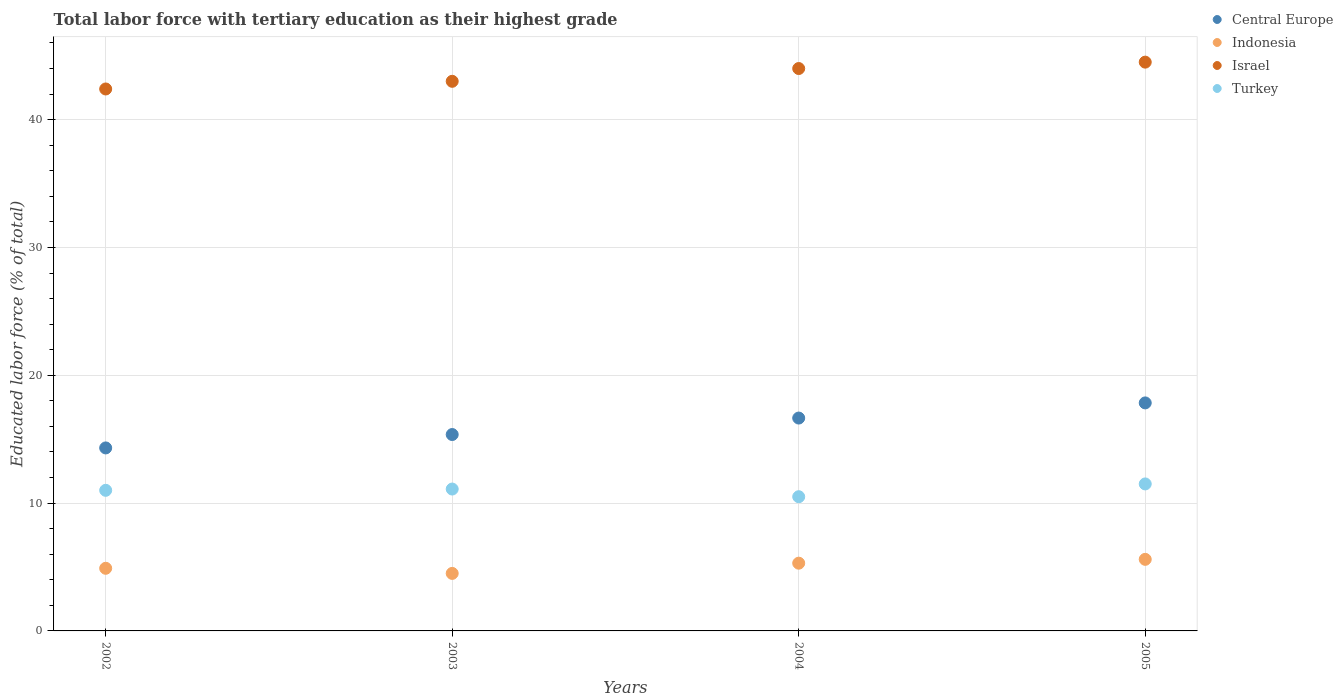How many different coloured dotlines are there?
Keep it short and to the point. 4. Is the number of dotlines equal to the number of legend labels?
Your answer should be very brief. Yes. What is the percentage of male labor force with tertiary education in Indonesia in 2005?
Give a very brief answer. 5.6. Across all years, what is the maximum percentage of male labor force with tertiary education in Turkey?
Offer a very short reply. 11.5. Across all years, what is the minimum percentage of male labor force with tertiary education in Israel?
Keep it short and to the point. 42.4. What is the total percentage of male labor force with tertiary education in Turkey in the graph?
Your answer should be compact. 44.1. What is the difference between the percentage of male labor force with tertiary education in Central Europe in 2002 and that in 2004?
Your response must be concise. -2.34. What is the difference between the percentage of male labor force with tertiary education in Turkey in 2004 and the percentage of male labor force with tertiary education in Indonesia in 2002?
Offer a very short reply. 5.6. What is the average percentage of male labor force with tertiary education in Central Europe per year?
Your answer should be very brief. 16.04. In the year 2004, what is the difference between the percentage of male labor force with tertiary education in Central Europe and percentage of male labor force with tertiary education in Indonesia?
Provide a succinct answer. 11.35. What is the ratio of the percentage of male labor force with tertiary education in Israel in 2003 to that in 2005?
Your answer should be compact. 0.97. Is the percentage of male labor force with tertiary education in Turkey in 2003 less than that in 2005?
Keep it short and to the point. Yes. Is the difference between the percentage of male labor force with tertiary education in Central Europe in 2003 and 2005 greater than the difference between the percentage of male labor force with tertiary education in Indonesia in 2003 and 2005?
Offer a very short reply. No. What is the difference between the highest and the second highest percentage of male labor force with tertiary education in Turkey?
Offer a very short reply. 0.4. What is the difference between the highest and the lowest percentage of male labor force with tertiary education in Central Europe?
Provide a succinct answer. 3.52. Is it the case that in every year, the sum of the percentage of male labor force with tertiary education in Indonesia and percentage of male labor force with tertiary education in Turkey  is greater than the percentage of male labor force with tertiary education in Israel?
Provide a short and direct response. No. How many years are there in the graph?
Keep it short and to the point. 4. What is the difference between two consecutive major ticks on the Y-axis?
Offer a terse response. 10. Are the values on the major ticks of Y-axis written in scientific E-notation?
Offer a very short reply. No. Does the graph contain any zero values?
Your answer should be compact. No. Does the graph contain grids?
Offer a terse response. Yes. Where does the legend appear in the graph?
Make the answer very short. Top right. How many legend labels are there?
Offer a terse response. 4. How are the legend labels stacked?
Provide a short and direct response. Vertical. What is the title of the graph?
Provide a succinct answer. Total labor force with tertiary education as their highest grade. Does "Swaziland" appear as one of the legend labels in the graph?
Provide a succinct answer. No. What is the label or title of the X-axis?
Keep it short and to the point. Years. What is the label or title of the Y-axis?
Offer a terse response. Educated labor force (% of total). What is the Educated labor force (% of total) in Central Europe in 2002?
Provide a succinct answer. 14.32. What is the Educated labor force (% of total) of Indonesia in 2002?
Offer a terse response. 4.9. What is the Educated labor force (% of total) of Israel in 2002?
Provide a succinct answer. 42.4. What is the Educated labor force (% of total) in Central Europe in 2003?
Your response must be concise. 15.37. What is the Educated labor force (% of total) in Indonesia in 2003?
Make the answer very short. 4.5. What is the Educated labor force (% of total) in Israel in 2003?
Your answer should be very brief. 43. What is the Educated labor force (% of total) in Turkey in 2003?
Your response must be concise. 11.1. What is the Educated labor force (% of total) in Central Europe in 2004?
Your answer should be very brief. 16.65. What is the Educated labor force (% of total) of Indonesia in 2004?
Offer a terse response. 5.3. What is the Educated labor force (% of total) of Israel in 2004?
Make the answer very short. 44. What is the Educated labor force (% of total) in Central Europe in 2005?
Offer a very short reply. 17.84. What is the Educated labor force (% of total) of Indonesia in 2005?
Keep it short and to the point. 5.6. What is the Educated labor force (% of total) of Israel in 2005?
Provide a succinct answer. 44.5. What is the Educated labor force (% of total) of Turkey in 2005?
Offer a terse response. 11.5. Across all years, what is the maximum Educated labor force (% of total) in Central Europe?
Ensure brevity in your answer.  17.84. Across all years, what is the maximum Educated labor force (% of total) in Indonesia?
Offer a very short reply. 5.6. Across all years, what is the maximum Educated labor force (% of total) in Israel?
Your answer should be compact. 44.5. Across all years, what is the minimum Educated labor force (% of total) of Central Europe?
Your answer should be very brief. 14.32. Across all years, what is the minimum Educated labor force (% of total) in Israel?
Your response must be concise. 42.4. What is the total Educated labor force (% of total) of Central Europe in the graph?
Your answer should be compact. 64.18. What is the total Educated labor force (% of total) in Indonesia in the graph?
Offer a very short reply. 20.3. What is the total Educated labor force (% of total) of Israel in the graph?
Offer a terse response. 173.9. What is the total Educated labor force (% of total) in Turkey in the graph?
Keep it short and to the point. 44.1. What is the difference between the Educated labor force (% of total) in Central Europe in 2002 and that in 2003?
Your answer should be compact. -1.05. What is the difference between the Educated labor force (% of total) in Indonesia in 2002 and that in 2003?
Offer a terse response. 0.4. What is the difference between the Educated labor force (% of total) of Central Europe in 2002 and that in 2004?
Provide a succinct answer. -2.34. What is the difference between the Educated labor force (% of total) of Indonesia in 2002 and that in 2004?
Keep it short and to the point. -0.4. What is the difference between the Educated labor force (% of total) in Turkey in 2002 and that in 2004?
Ensure brevity in your answer.  0.5. What is the difference between the Educated labor force (% of total) in Central Europe in 2002 and that in 2005?
Make the answer very short. -3.52. What is the difference between the Educated labor force (% of total) of Central Europe in 2003 and that in 2004?
Offer a very short reply. -1.29. What is the difference between the Educated labor force (% of total) of Israel in 2003 and that in 2004?
Provide a short and direct response. -1. What is the difference between the Educated labor force (% of total) in Turkey in 2003 and that in 2004?
Offer a terse response. 0.6. What is the difference between the Educated labor force (% of total) in Central Europe in 2003 and that in 2005?
Your answer should be very brief. -2.47. What is the difference between the Educated labor force (% of total) of Central Europe in 2004 and that in 2005?
Ensure brevity in your answer.  -1.19. What is the difference between the Educated labor force (% of total) in Indonesia in 2004 and that in 2005?
Your answer should be compact. -0.3. What is the difference between the Educated labor force (% of total) of Israel in 2004 and that in 2005?
Your answer should be very brief. -0.5. What is the difference between the Educated labor force (% of total) of Central Europe in 2002 and the Educated labor force (% of total) of Indonesia in 2003?
Your answer should be very brief. 9.82. What is the difference between the Educated labor force (% of total) in Central Europe in 2002 and the Educated labor force (% of total) in Israel in 2003?
Provide a succinct answer. -28.68. What is the difference between the Educated labor force (% of total) of Central Europe in 2002 and the Educated labor force (% of total) of Turkey in 2003?
Your answer should be very brief. 3.22. What is the difference between the Educated labor force (% of total) of Indonesia in 2002 and the Educated labor force (% of total) of Israel in 2003?
Provide a short and direct response. -38.1. What is the difference between the Educated labor force (% of total) in Indonesia in 2002 and the Educated labor force (% of total) in Turkey in 2003?
Make the answer very short. -6.2. What is the difference between the Educated labor force (% of total) of Israel in 2002 and the Educated labor force (% of total) of Turkey in 2003?
Make the answer very short. 31.3. What is the difference between the Educated labor force (% of total) of Central Europe in 2002 and the Educated labor force (% of total) of Indonesia in 2004?
Your response must be concise. 9.02. What is the difference between the Educated labor force (% of total) in Central Europe in 2002 and the Educated labor force (% of total) in Israel in 2004?
Keep it short and to the point. -29.68. What is the difference between the Educated labor force (% of total) of Central Europe in 2002 and the Educated labor force (% of total) of Turkey in 2004?
Keep it short and to the point. 3.82. What is the difference between the Educated labor force (% of total) of Indonesia in 2002 and the Educated labor force (% of total) of Israel in 2004?
Your answer should be very brief. -39.1. What is the difference between the Educated labor force (% of total) of Indonesia in 2002 and the Educated labor force (% of total) of Turkey in 2004?
Provide a succinct answer. -5.6. What is the difference between the Educated labor force (% of total) of Israel in 2002 and the Educated labor force (% of total) of Turkey in 2004?
Your response must be concise. 31.9. What is the difference between the Educated labor force (% of total) of Central Europe in 2002 and the Educated labor force (% of total) of Indonesia in 2005?
Ensure brevity in your answer.  8.72. What is the difference between the Educated labor force (% of total) of Central Europe in 2002 and the Educated labor force (% of total) of Israel in 2005?
Provide a succinct answer. -30.18. What is the difference between the Educated labor force (% of total) in Central Europe in 2002 and the Educated labor force (% of total) in Turkey in 2005?
Offer a very short reply. 2.82. What is the difference between the Educated labor force (% of total) of Indonesia in 2002 and the Educated labor force (% of total) of Israel in 2005?
Provide a succinct answer. -39.6. What is the difference between the Educated labor force (% of total) of Indonesia in 2002 and the Educated labor force (% of total) of Turkey in 2005?
Offer a very short reply. -6.6. What is the difference between the Educated labor force (% of total) of Israel in 2002 and the Educated labor force (% of total) of Turkey in 2005?
Offer a terse response. 30.9. What is the difference between the Educated labor force (% of total) of Central Europe in 2003 and the Educated labor force (% of total) of Indonesia in 2004?
Offer a very short reply. 10.06. What is the difference between the Educated labor force (% of total) in Central Europe in 2003 and the Educated labor force (% of total) in Israel in 2004?
Your response must be concise. -28.64. What is the difference between the Educated labor force (% of total) in Central Europe in 2003 and the Educated labor force (% of total) in Turkey in 2004?
Ensure brevity in your answer.  4.87. What is the difference between the Educated labor force (% of total) of Indonesia in 2003 and the Educated labor force (% of total) of Israel in 2004?
Your response must be concise. -39.5. What is the difference between the Educated labor force (% of total) of Israel in 2003 and the Educated labor force (% of total) of Turkey in 2004?
Offer a very short reply. 32.5. What is the difference between the Educated labor force (% of total) of Central Europe in 2003 and the Educated labor force (% of total) of Indonesia in 2005?
Provide a short and direct response. 9.77. What is the difference between the Educated labor force (% of total) of Central Europe in 2003 and the Educated labor force (% of total) of Israel in 2005?
Your answer should be very brief. -29.14. What is the difference between the Educated labor force (% of total) of Central Europe in 2003 and the Educated labor force (% of total) of Turkey in 2005?
Give a very brief answer. 3.87. What is the difference between the Educated labor force (% of total) in Israel in 2003 and the Educated labor force (% of total) in Turkey in 2005?
Your response must be concise. 31.5. What is the difference between the Educated labor force (% of total) of Central Europe in 2004 and the Educated labor force (% of total) of Indonesia in 2005?
Keep it short and to the point. 11.05. What is the difference between the Educated labor force (% of total) of Central Europe in 2004 and the Educated labor force (% of total) of Israel in 2005?
Your answer should be compact. -27.85. What is the difference between the Educated labor force (% of total) of Central Europe in 2004 and the Educated labor force (% of total) of Turkey in 2005?
Provide a succinct answer. 5.15. What is the difference between the Educated labor force (% of total) of Indonesia in 2004 and the Educated labor force (% of total) of Israel in 2005?
Your response must be concise. -39.2. What is the difference between the Educated labor force (% of total) in Indonesia in 2004 and the Educated labor force (% of total) in Turkey in 2005?
Provide a short and direct response. -6.2. What is the difference between the Educated labor force (% of total) of Israel in 2004 and the Educated labor force (% of total) of Turkey in 2005?
Offer a terse response. 32.5. What is the average Educated labor force (% of total) in Central Europe per year?
Your answer should be compact. 16.04. What is the average Educated labor force (% of total) in Indonesia per year?
Your answer should be very brief. 5.08. What is the average Educated labor force (% of total) of Israel per year?
Make the answer very short. 43.48. What is the average Educated labor force (% of total) of Turkey per year?
Keep it short and to the point. 11.03. In the year 2002, what is the difference between the Educated labor force (% of total) of Central Europe and Educated labor force (% of total) of Indonesia?
Make the answer very short. 9.42. In the year 2002, what is the difference between the Educated labor force (% of total) of Central Europe and Educated labor force (% of total) of Israel?
Ensure brevity in your answer.  -28.08. In the year 2002, what is the difference between the Educated labor force (% of total) of Central Europe and Educated labor force (% of total) of Turkey?
Your answer should be very brief. 3.32. In the year 2002, what is the difference between the Educated labor force (% of total) in Indonesia and Educated labor force (% of total) in Israel?
Offer a terse response. -37.5. In the year 2002, what is the difference between the Educated labor force (% of total) of Israel and Educated labor force (% of total) of Turkey?
Give a very brief answer. 31.4. In the year 2003, what is the difference between the Educated labor force (% of total) in Central Europe and Educated labor force (% of total) in Indonesia?
Keep it short and to the point. 10.87. In the year 2003, what is the difference between the Educated labor force (% of total) in Central Europe and Educated labor force (% of total) in Israel?
Ensure brevity in your answer.  -27.64. In the year 2003, what is the difference between the Educated labor force (% of total) in Central Europe and Educated labor force (% of total) in Turkey?
Your answer should be very brief. 4.26. In the year 2003, what is the difference between the Educated labor force (% of total) of Indonesia and Educated labor force (% of total) of Israel?
Provide a short and direct response. -38.5. In the year 2003, what is the difference between the Educated labor force (% of total) in Israel and Educated labor force (% of total) in Turkey?
Offer a terse response. 31.9. In the year 2004, what is the difference between the Educated labor force (% of total) of Central Europe and Educated labor force (% of total) of Indonesia?
Give a very brief answer. 11.35. In the year 2004, what is the difference between the Educated labor force (% of total) of Central Europe and Educated labor force (% of total) of Israel?
Make the answer very short. -27.35. In the year 2004, what is the difference between the Educated labor force (% of total) of Central Europe and Educated labor force (% of total) of Turkey?
Provide a short and direct response. 6.15. In the year 2004, what is the difference between the Educated labor force (% of total) in Indonesia and Educated labor force (% of total) in Israel?
Offer a very short reply. -38.7. In the year 2004, what is the difference between the Educated labor force (% of total) of Indonesia and Educated labor force (% of total) of Turkey?
Your response must be concise. -5.2. In the year 2004, what is the difference between the Educated labor force (% of total) of Israel and Educated labor force (% of total) of Turkey?
Make the answer very short. 33.5. In the year 2005, what is the difference between the Educated labor force (% of total) of Central Europe and Educated labor force (% of total) of Indonesia?
Your response must be concise. 12.24. In the year 2005, what is the difference between the Educated labor force (% of total) of Central Europe and Educated labor force (% of total) of Israel?
Keep it short and to the point. -26.66. In the year 2005, what is the difference between the Educated labor force (% of total) of Central Europe and Educated labor force (% of total) of Turkey?
Give a very brief answer. 6.34. In the year 2005, what is the difference between the Educated labor force (% of total) in Indonesia and Educated labor force (% of total) in Israel?
Make the answer very short. -38.9. In the year 2005, what is the difference between the Educated labor force (% of total) of Indonesia and Educated labor force (% of total) of Turkey?
Your response must be concise. -5.9. What is the ratio of the Educated labor force (% of total) of Central Europe in 2002 to that in 2003?
Your response must be concise. 0.93. What is the ratio of the Educated labor force (% of total) in Indonesia in 2002 to that in 2003?
Your response must be concise. 1.09. What is the ratio of the Educated labor force (% of total) of Turkey in 2002 to that in 2003?
Offer a very short reply. 0.99. What is the ratio of the Educated labor force (% of total) of Central Europe in 2002 to that in 2004?
Ensure brevity in your answer.  0.86. What is the ratio of the Educated labor force (% of total) in Indonesia in 2002 to that in 2004?
Keep it short and to the point. 0.92. What is the ratio of the Educated labor force (% of total) of Israel in 2002 to that in 2004?
Offer a terse response. 0.96. What is the ratio of the Educated labor force (% of total) in Turkey in 2002 to that in 2004?
Offer a terse response. 1.05. What is the ratio of the Educated labor force (% of total) of Central Europe in 2002 to that in 2005?
Offer a very short reply. 0.8. What is the ratio of the Educated labor force (% of total) in Israel in 2002 to that in 2005?
Your answer should be compact. 0.95. What is the ratio of the Educated labor force (% of total) in Turkey in 2002 to that in 2005?
Give a very brief answer. 0.96. What is the ratio of the Educated labor force (% of total) of Central Europe in 2003 to that in 2004?
Your response must be concise. 0.92. What is the ratio of the Educated labor force (% of total) of Indonesia in 2003 to that in 2004?
Provide a succinct answer. 0.85. What is the ratio of the Educated labor force (% of total) in Israel in 2003 to that in 2004?
Make the answer very short. 0.98. What is the ratio of the Educated labor force (% of total) in Turkey in 2003 to that in 2004?
Make the answer very short. 1.06. What is the ratio of the Educated labor force (% of total) in Central Europe in 2003 to that in 2005?
Your answer should be very brief. 0.86. What is the ratio of the Educated labor force (% of total) of Indonesia in 2003 to that in 2005?
Make the answer very short. 0.8. What is the ratio of the Educated labor force (% of total) of Israel in 2003 to that in 2005?
Provide a short and direct response. 0.97. What is the ratio of the Educated labor force (% of total) of Turkey in 2003 to that in 2005?
Offer a very short reply. 0.97. What is the ratio of the Educated labor force (% of total) of Central Europe in 2004 to that in 2005?
Provide a short and direct response. 0.93. What is the ratio of the Educated labor force (% of total) of Indonesia in 2004 to that in 2005?
Ensure brevity in your answer.  0.95. What is the difference between the highest and the second highest Educated labor force (% of total) in Central Europe?
Make the answer very short. 1.19. What is the difference between the highest and the second highest Educated labor force (% of total) in Indonesia?
Your response must be concise. 0.3. What is the difference between the highest and the second highest Educated labor force (% of total) in Turkey?
Your answer should be very brief. 0.4. What is the difference between the highest and the lowest Educated labor force (% of total) in Central Europe?
Provide a succinct answer. 3.52. What is the difference between the highest and the lowest Educated labor force (% of total) of Israel?
Make the answer very short. 2.1. What is the difference between the highest and the lowest Educated labor force (% of total) of Turkey?
Provide a succinct answer. 1. 